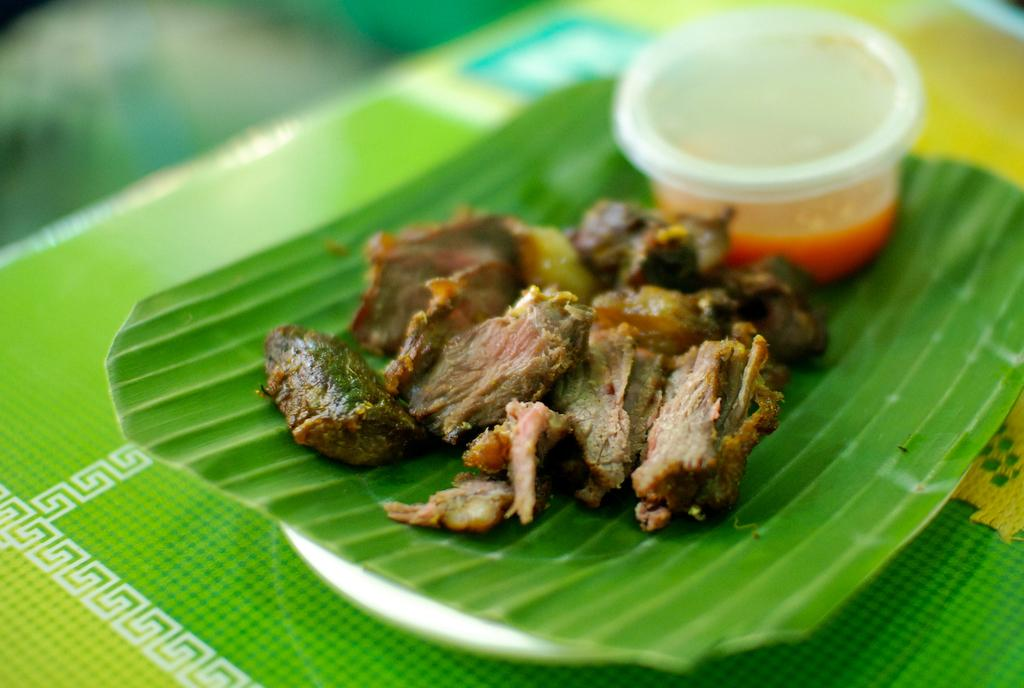What color is the plate that is visible in the image? The plate is green in color. What is on the plate in the image? There is a food item and another object on the plate. Can you describe the other object on the plate? Unfortunately, the facts provided do not give any details about the other object on the plate. Where is the plate located in the image? The plate is on a surface in the image. What type of mist can be seen surrounding the plate in the image? There is no mist present in the image; it features a plate with a food item and another object on it. How does the wren interact with the wax in the image? There is no wren or wax present in the image. 